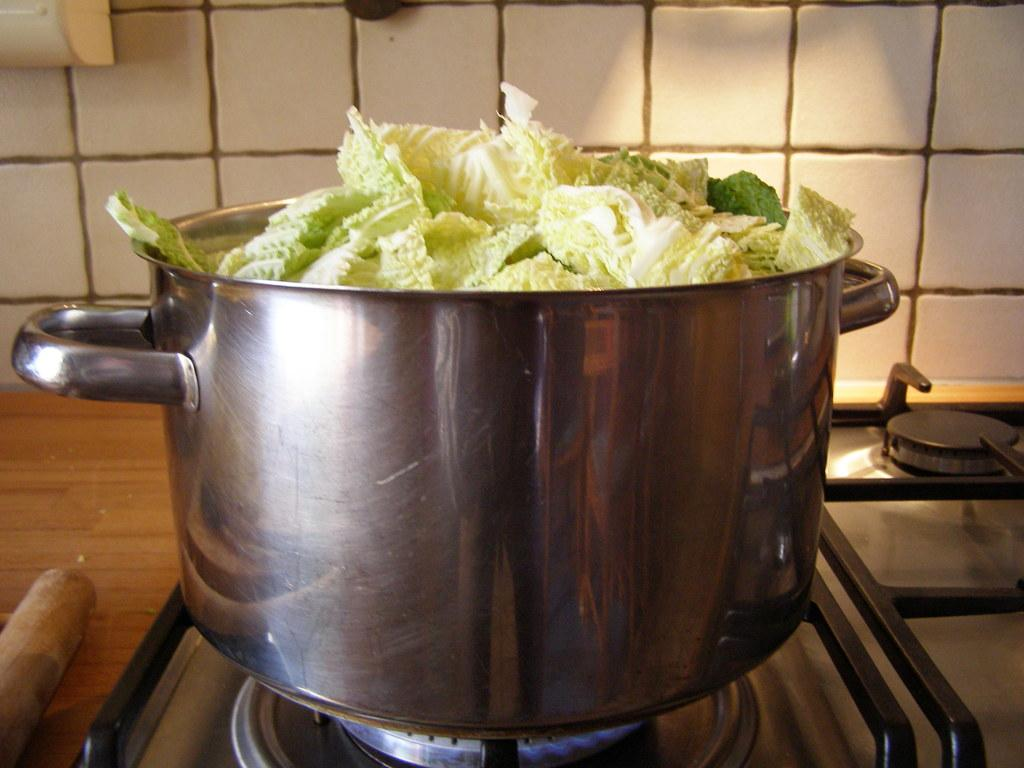What is in the vessel that is visible in the image? There is a food in a vessel in the image. Where is the vessel placed in the image? The vessel is placed on a stove. What can be seen in the background of the image? There is a wall in the background of the image. What type of afterthought is being expressed by the food in the image? There is no afterthought being expressed by the food in the image, as it is an inanimate object. 